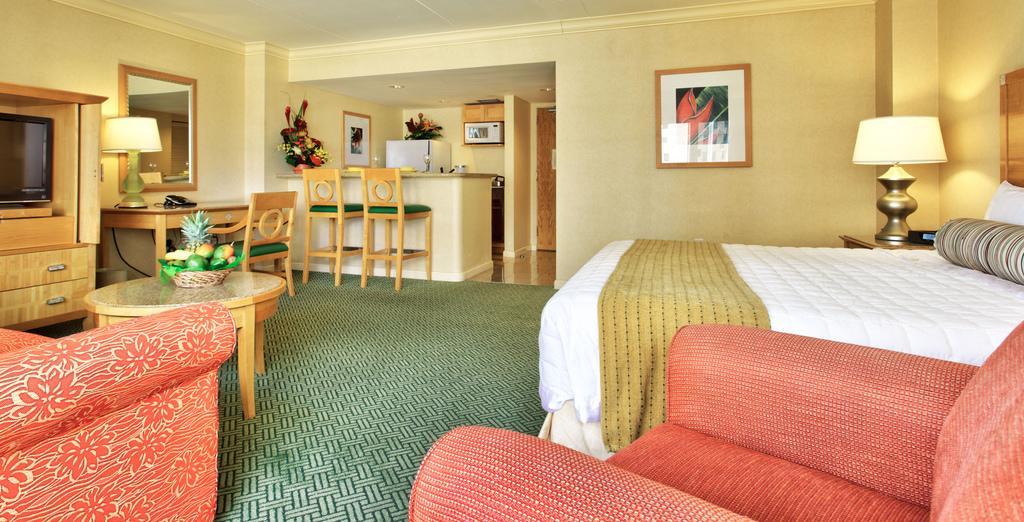Describe this image in one or two sentences. In this picture, we can see inner view of the room, we can see bed, pillows, chairs, sofa, tables and some objects on the table, we can see shelves and some objects in it, we can see television, refrigerator, and we can see the roof with lights, and photo frames. 